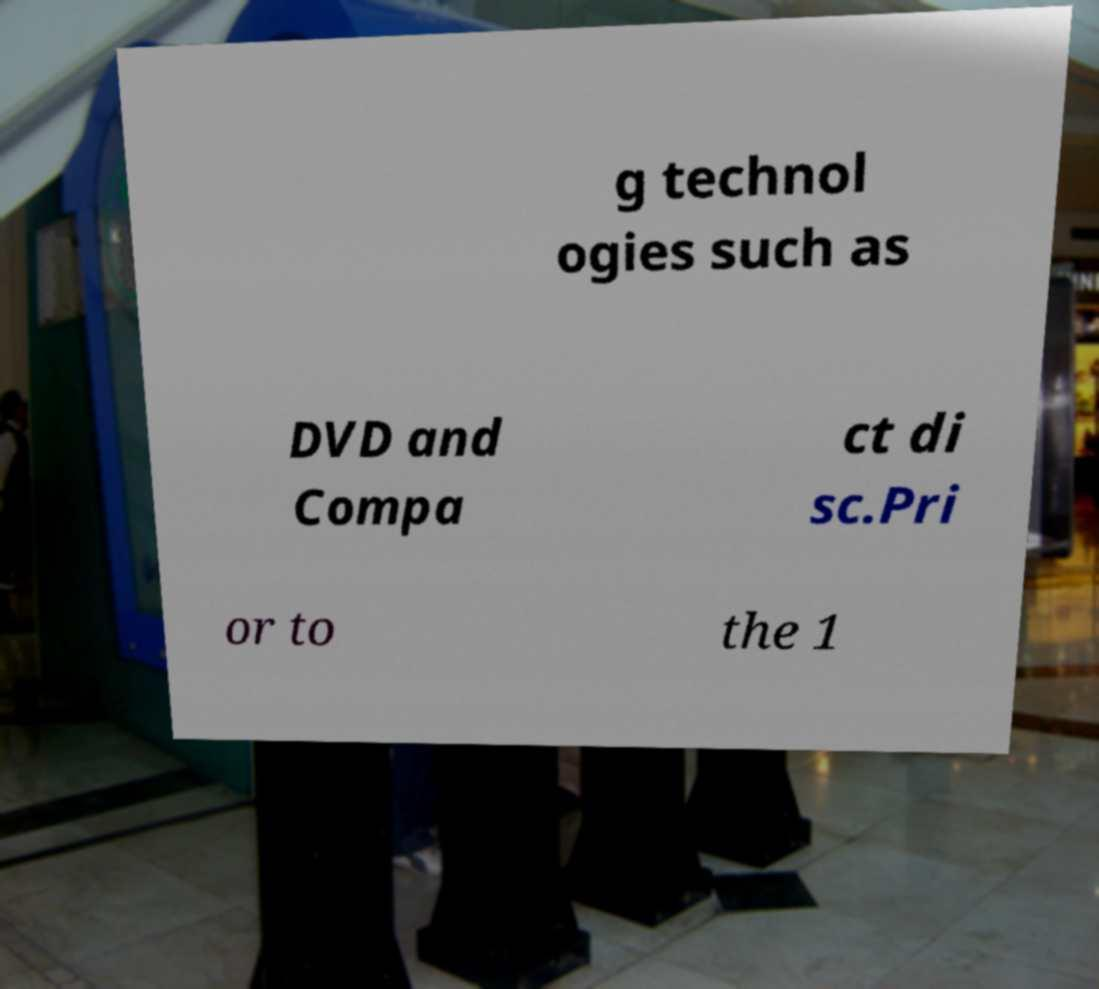Please read and relay the text visible in this image. What does it say? g technol ogies such as DVD and Compa ct di sc.Pri or to the 1 